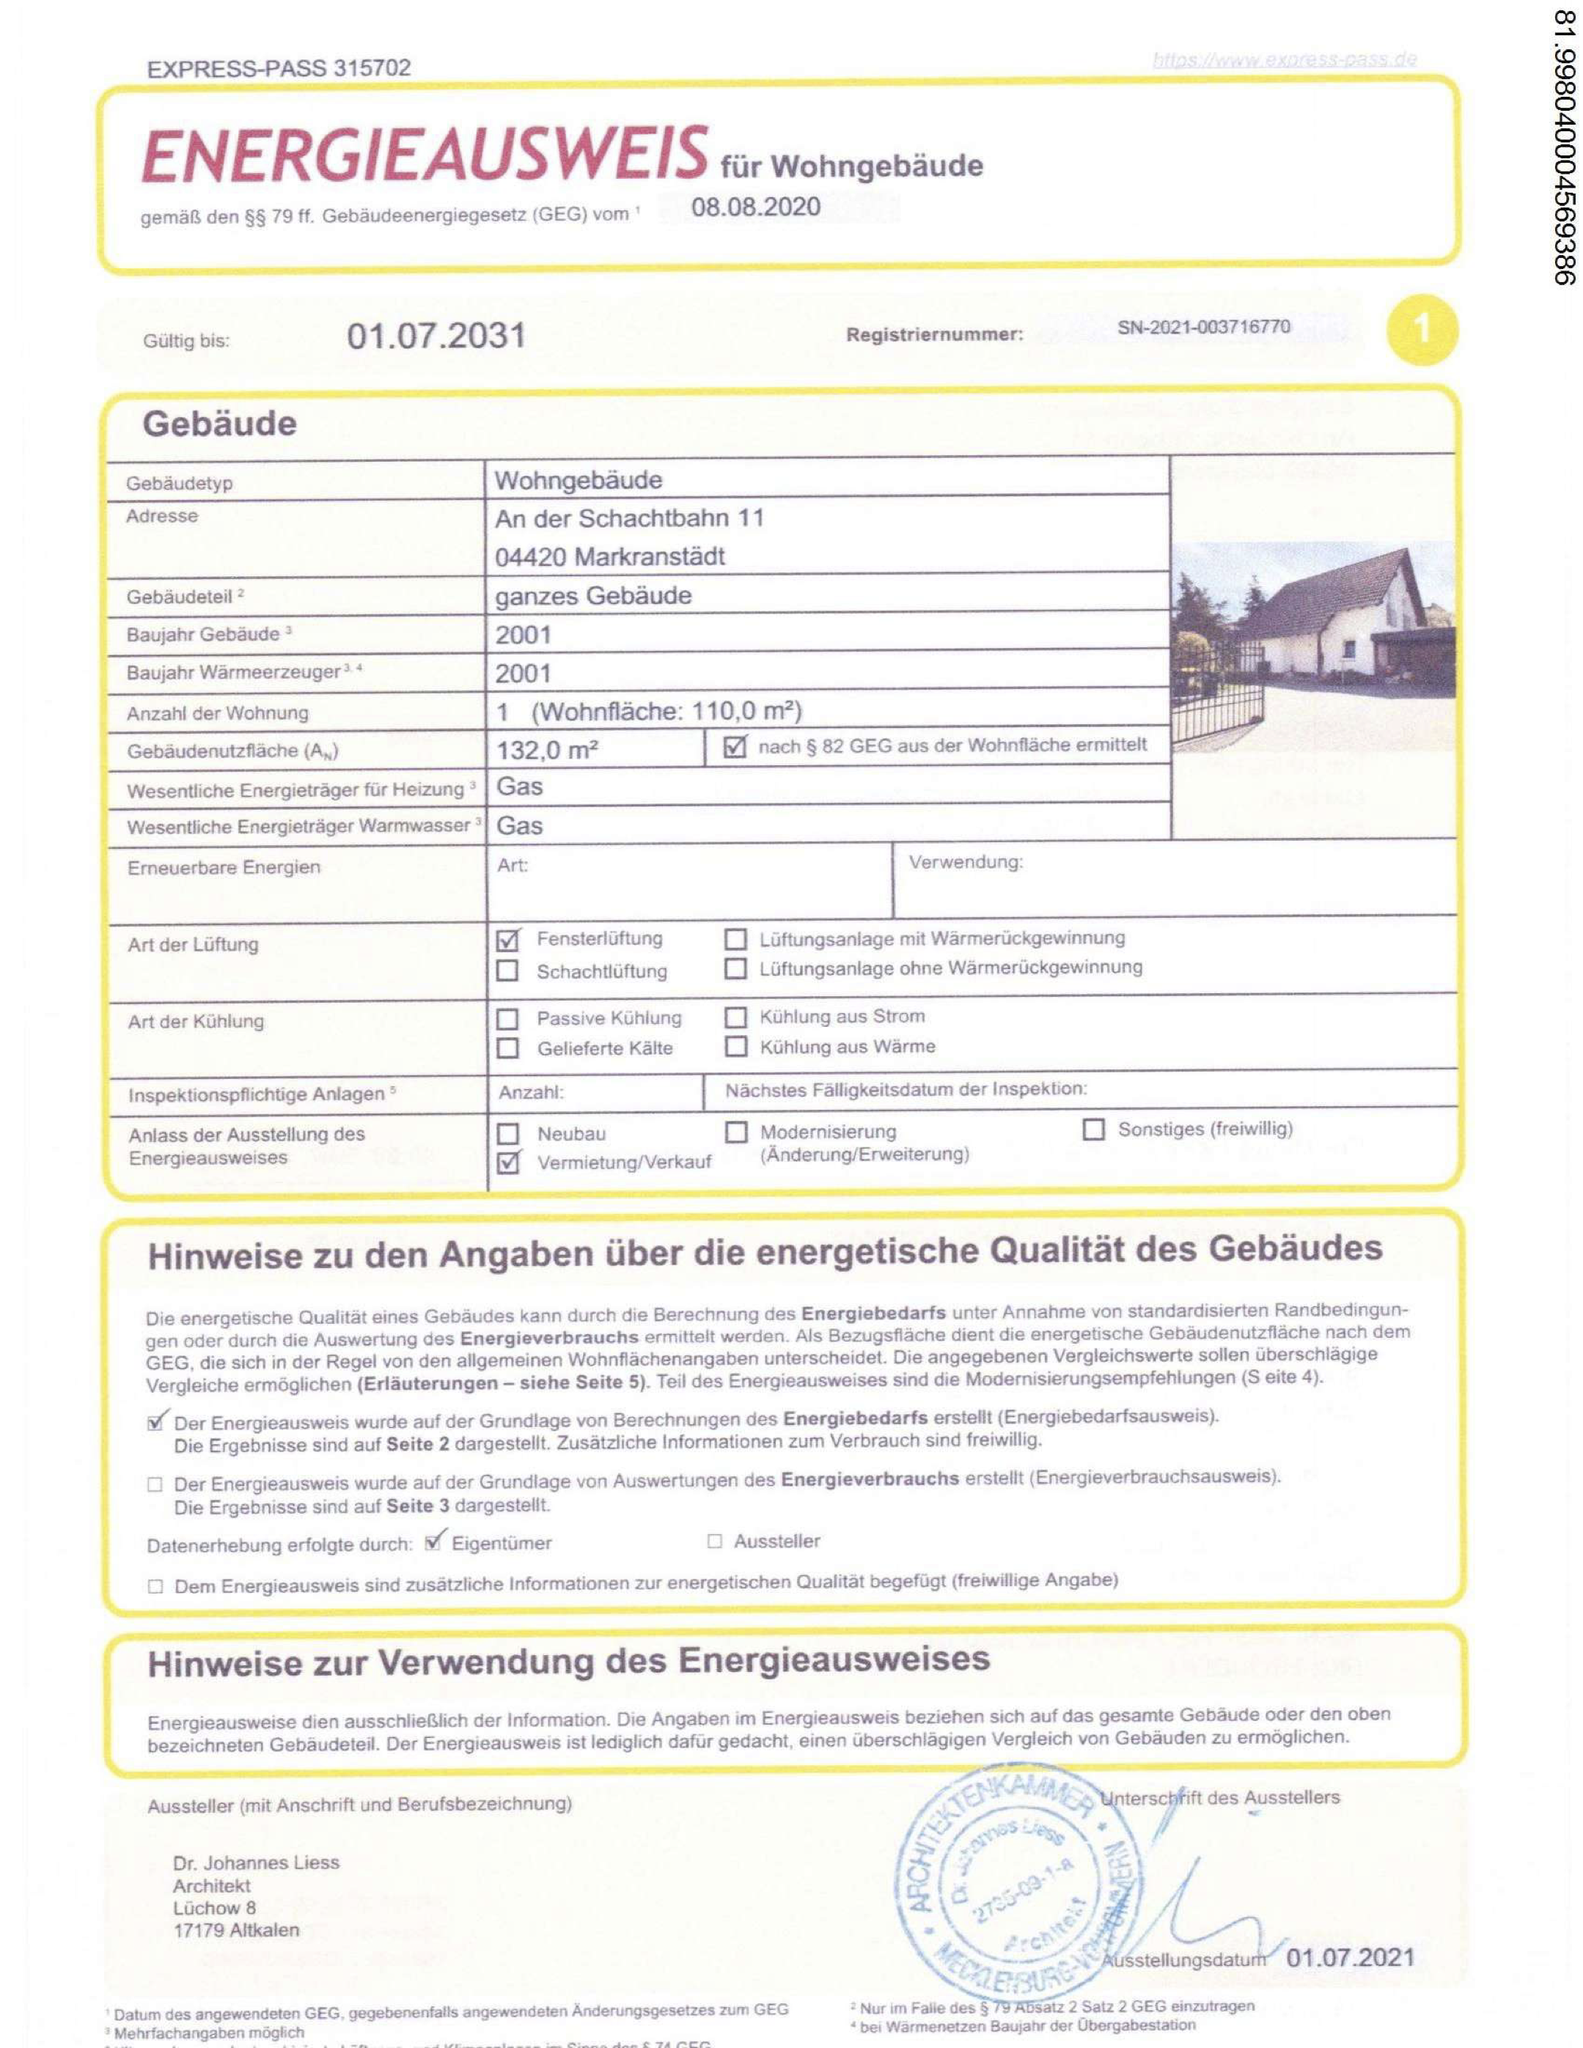Wurde die Gebäudenutzfläche nach § 82 GEG aus der Wohnfläche ermittelt? Ja, laut dem Dokument wurde die Gebäudenutzfläche (A) von 132,0 m² nach § 82 GEG aus der Wohnfläche ermittelt. Dies ist im Abschnitt "Gebäude" unter der Rubrik "Gebäudenutzfläche (A)" angegeben, wo explizit "nach § 82 GEG aus der Wohnfläche ermittelt" steht. Welche Arten der Lüftung gibt es in dem Objekt? In dem abgebildeten Energieausweis für Wohngebäude sind unter der Rubrik "Art der Lüftung" zwei Arten der Lüftung angekreuzt:

1. Fensterlüftung: Dies bedeutet, dass die Lüftung des Gebäudes durch das Öffnen von Fenstern erfolgt. Es handelt sich um eine manuelle Lüftungsmethode, bei der die Bewohner selbst für den Luftaustausch sorgen müssen.

2. Lüftungsanlage mit Wärmerückgewinnung: Hierbei handelt es sich um ein mechanisches Lüftungssystem, das verbrauchte Luft aus dem Gebäude abführt und gleichzeitig frische Luft von außen zuführt. Die Wärmerückgewinnung ermöglicht es, dass die Wärme aus der abgeführten Luft genutzt wird, um die zugeführte Frischluft vorzuwärmen, was zu einer Energieeinsparung führt.

Die anderen Optionen, wie Schachtlüftung, Lüftungsanlage ohne Wärmerückgewinnung, passive Kühlung, Kühlung aus Strom, Kühlung aus Wärme und gefilterte Kälte, sind nicht angekreuzt und somit nicht als Lüftungsarten für dieses Gebäude angegeben. 